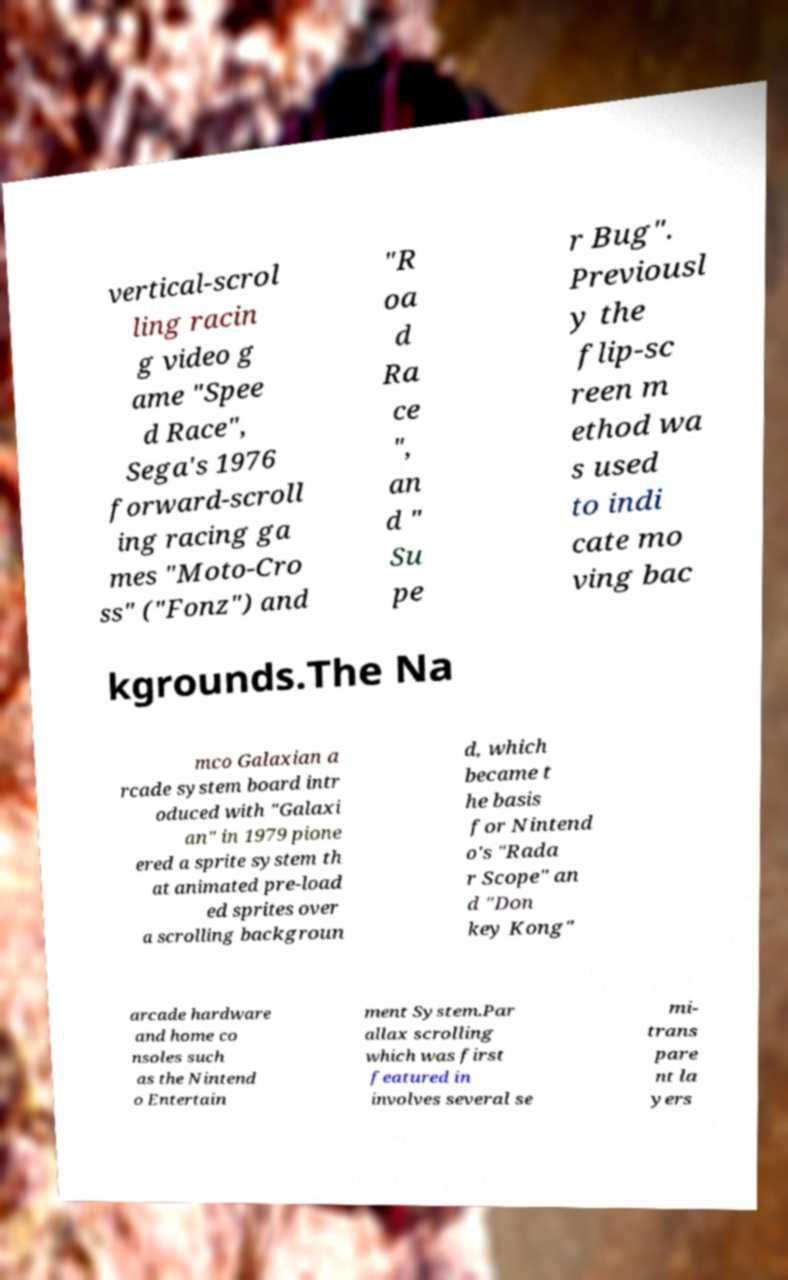I need the written content from this picture converted into text. Can you do that? vertical-scrol ling racin g video g ame "Spee d Race", Sega's 1976 forward-scroll ing racing ga mes "Moto-Cro ss" ("Fonz") and "R oa d Ra ce ", an d " Su pe r Bug". Previousl y the flip-sc reen m ethod wa s used to indi cate mo ving bac kgrounds.The Na mco Galaxian a rcade system board intr oduced with "Galaxi an" in 1979 pione ered a sprite system th at animated pre-load ed sprites over a scrolling backgroun d, which became t he basis for Nintend o's "Rada r Scope" an d "Don key Kong" arcade hardware and home co nsoles such as the Nintend o Entertain ment System.Par allax scrolling which was first featured in involves several se mi- trans pare nt la yers 